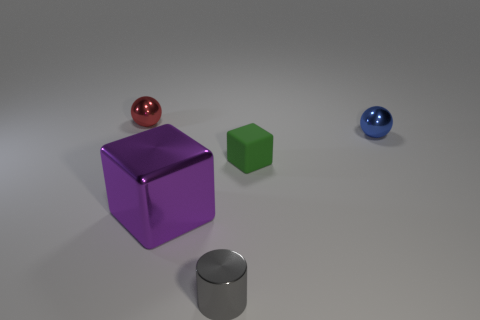How many shiny things are either yellow cylinders or tiny green blocks?
Provide a succinct answer. 0. What shape is the tiny green thing?
Give a very brief answer. Cube. Are there any other things that are the same material as the tiny green cube?
Your answer should be compact. No. Does the green cube have the same material as the gray cylinder?
Your answer should be very brief. No. There is a cube that is on the left side of the tiny metal object in front of the blue sphere; is there a small blue metallic ball that is in front of it?
Give a very brief answer. No. How many other objects are the same shape as the tiny gray metallic object?
Ensure brevity in your answer.  0. The small metallic object that is behind the gray metal object and on the left side of the tiny green object has what shape?
Your answer should be very brief. Sphere. There is a tiny metallic thing in front of the small sphere in front of the small object that is on the left side of the small cylinder; what color is it?
Keep it short and to the point. Gray. Is the number of small metallic objects that are in front of the tiny blue metal thing greater than the number of tiny spheres that are on the right side of the green rubber block?
Provide a short and direct response. No. How many other things are there of the same size as the gray cylinder?
Give a very brief answer. 3. 